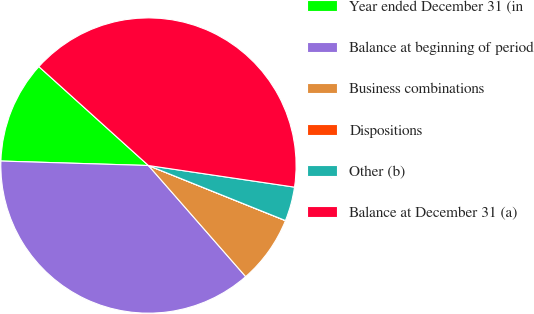Convert chart to OTSL. <chart><loc_0><loc_0><loc_500><loc_500><pie_chart><fcel>Year ended December 31 (in<fcel>Balance at beginning of period<fcel>Business combinations<fcel>Dispositions<fcel>Other (b)<fcel>Balance at December 31 (a)<nl><fcel>11.2%<fcel>36.92%<fcel>7.47%<fcel>0.01%<fcel>3.74%<fcel>40.65%<nl></chart> 